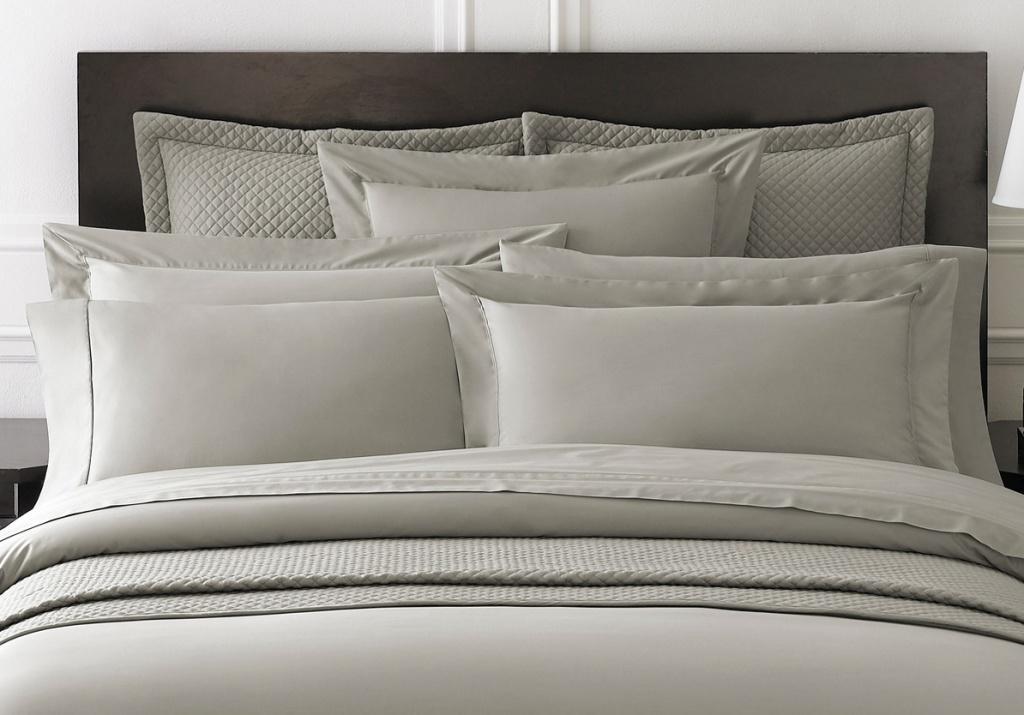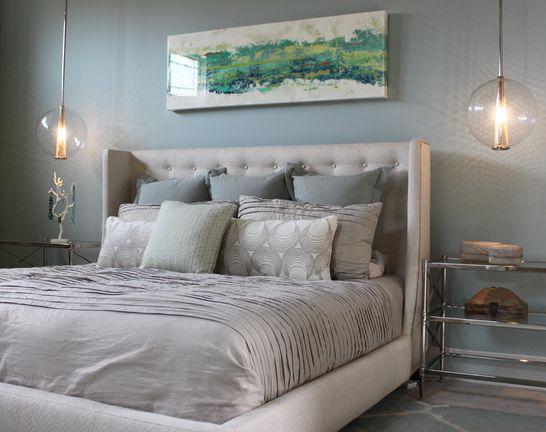The first image is the image on the left, the second image is the image on the right. Examine the images to the left and right. Is the description "A person is laying in the bed in the image on the left." accurate? Answer yes or no. No. The first image is the image on the left, the second image is the image on the right. Assess this claim about the two images: "An image shows a person with bare legs on a bed next to a window with a fabric drape.". Correct or not? Answer yes or no. No. 